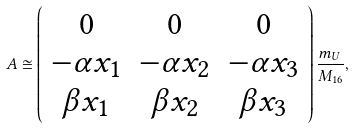Convert formula to latex. <formula><loc_0><loc_0><loc_500><loc_500>A \cong \left ( \begin{array} { c c c } 0 & 0 & 0 \\ - \alpha x _ { 1 } & - \alpha x _ { 2 } & - \alpha x _ { 3 } \\ \beta x _ { 1 } & \beta x _ { 2 } & \beta x _ { 3 } \end{array} \right ) \frac { m _ { U } } { M _ { 1 6 } } ,</formula> 